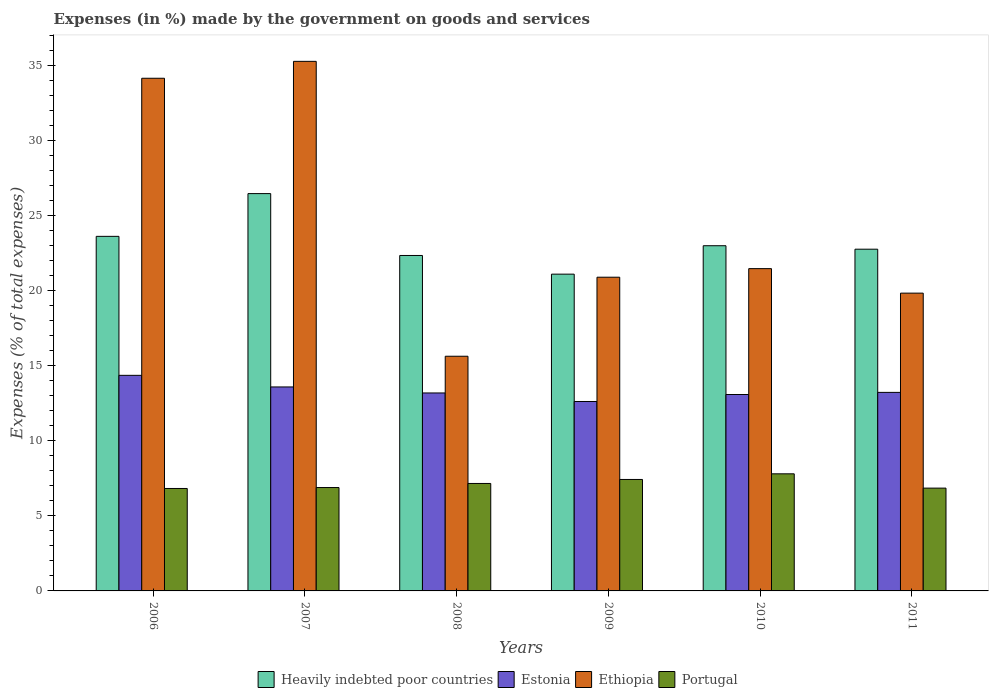How many different coloured bars are there?
Keep it short and to the point. 4. How many bars are there on the 4th tick from the left?
Give a very brief answer. 4. What is the label of the 3rd group of bars from the left?
Give a very brief answer. 2008. In how many cases, is the number of bars for a given year not equal to the number of legend labels?
Your answer should be compact. 0. What is the percentage of expenses made by the government on goods and services in Heavily indebted poor countries in 2010?
Offer a terse response. 23.01. Across all years, what is the maximum percentage of expenses made by the government on goods and services in Ethiopia?
Offer a very short reply. 35.3. Across all years, what is the minimum percentage of expenses made by the government on goods and services in Heavily indebted poor countries?
Keep it short and to the point. 21.11. In which year was the percentage of expenses made by the government on goods and services in Portugal maximum?
Your response must be concise. 2010. In which year was the percentage of expenses made by the government on goods and services in Estonia minimum?
Your answer should be very brief. 2009. What is the total percentage of expenses made by the government on goods and services in Heavily indebted poor countries in the graph?
Give a very brief answer. 139.37. What is the difference between the percentage of expenses made by the government on goods and services in Heavily indebted poor countries in 2009 and that in 2010?
Your answer should be very brief. -1.89. What is the difference between the percentage of expenses made by the government on goods and services in Estonia in 2007 and the percentage of expenses made by the government on goods and services in Heavily indebted poor countries in 2006?
Provide a short and direct response. -10.04. What is the average percentage of expenses made by the government on goods and services in Portugal per year?
Provide a short and direct response. 7.16. In the year 2011, what is the difference between the percentage of expenses made by the government on goods and services in Heavily indebted poor countries and percentage of expenses made by the government on goods and services in Portugal?
Provide a succinct answer. 15.92. In how many years, is the percentage of expenses made by the government on goods and services in Ethiopia greater than 15 %?
Ensure brevity in your answer.  6. What is the ratio of the percentage of expenses made by the government on goods and services in Portugal in 2007 to that in 2011?
Provide a succinct answer. 1.01. What is the difference between the highest and the second highest percentage of expenses made by the government on goods and services in Ethiopia?
Provide a short and direct response. 1.13. What is the difference between the highest and the lowest percentage of expenses made by the government on goods and services in Heavily indebted poor countries?
Keep it short and to the point. 5.37. Is the sum of the percentage of expenses made by the government on goods and services in Heavily indebted poor countries in 2008 and 2011 greater than the maximum percentage of expenses made by the government on goods and services in Estonia across all years?
Provide a short and direct response. Yes. Is it the case that in every year, the sum of the percentage of expenses made by the government on goods and services in Ethiopia and percentage of expenses made by the government on goods and services in Estonia is greater than the sum of percentage of expenses made by the government on goods and services in Portugal and percentage of expenses made by the government on goods and services in Heavily indebted poor countries?
Your response must be concise. Yes. What does the 4th bar from the left in 2007 represents?
Make the answer very short. Portugal. What does the 2nd bar from the right in 2006 represents?
Provide a succinct answer. Ethiopia. Is it the case that in every year, the sum of the percentage of expenses made by the government on goods and services in Heavily indebted poor countries and percentage of expenses made by the government on goods and services in Ethiopia is greater than the percentage of expenses made by the government on goods and services in Portugal?
Give a very brief answer. Yes. How many bars are there?
Your answer should be compact. 24. What is the difference between two consecutive major ticks on the Y-axis?
Your answer should be compact. 5. What is the title of the graph?
Offer a very short reply. Expenses (in %) made by the government on goods and services. What is the label or title of the X-axis?
Offer a terse response. Years. What is the label or title of the Y-axis?
Provide a short and direct response. Expenses (% of total expenses). What is the Expenses (% of total expenses) in Heavily indebted poor countries in 2006?
Make the answer very short. 23.63. What is the Expenses (% of total expenses) in Estonia in 2006?
Offer a terse response. 14.37. What is the Expenses (% of total expenses) of Ethiopia in 2006?
Offer a terse response. 34.17. What is the Expenses (% of total expenses) in Portugal in 2006?
Provide a short and direct response. 6.83. What is the Expenses (% of total expenses) in Heavily indebted poor countries in 2007?
Offer a very short reply. 26.48. What is the Expenses (% of total expenses) in Estonia in 2007?
Provide a short and direct response. 13.6. What is the Expenses (% of total expenses) of Ethiopia in 2007?
Provide a short and direct response. 35.3. What is the Expenses (% of total expenses) of Portugal in 2007?
Ensure brevity in your answer.  6.89. What is the Expenses (% of total expenses) in Heavily indebted poor countries in 2008?
Provide a short and direct response. 22.36. What is the Expenses (% of total expenses) in Estonia in 2008?
Offer a terse response. 13.19. What is the Expenses (% of total expenses) of Ethiopia in 2008?
Make the answer very short. 15.64. What is the Expenses (% of total expenses) of Portugal in 2008?
Keep it short and to the point. 7.16. What is the Expenses (% of total expenses) of Heavily indebted poor countries in 2009?
Keep it short and to the point. 21.11. What is the Expenses (% of total expenses) of Estonia in 2009?
Ensure brevity in your answer.  12.63. What is the Expenses (% of total expenses) of Ethiopia in 2009?
Provide a succinct answer. 20.91. What is the Expenses (% of total expenses) of Portugal in 2009?
Give a very brief answer. 7.43. What is the Expenses (% of total expenses) in Heavily indebted poor countries in 2010?
Keep it short and to the point. 23.01. What is the Expenses (% of total expenses) in Estonia in 2010?
Provide a short and direct response. 13.09. What is the Expenses (% of total expenses) of Ethiopia in 2010?
Ensure brevity in your answer.  21.48. What is the Expenses (% of total expenses) of Portugal in 2010?
Your response must be concise. 7.8. What is the Expenses (% of total expenses) of Heavily indebted poor countries in 2011?
Your answer should be compact. 22.78. What is the Expenses (% of total expenses) of Estonia in 2011?
Your response must be concise. 13.23. What is the Expenses (% of total expenses) of Ethiopia in 2011?
Keep it short and to the point. 19.85. What is the Expenses (% of total expenses) of Portugal in 2011?
Provide a short and direct response. 6.85. Across all years, what is the maximum Expenses (% of total expenses) in Heavily indebted poor countries?
Give a very brief answer. 26.48. Across all years, what is the maximum Expenses (% of total expenses) of Estonia?
Offer a very short reply. 14.37. Across all years, what is the maximum Expenses (% of total expenses) in Ethiopia?
Your response must be concise. 35.3. Across all years, what is the maximum Expenses (% of total expenses) in Portugal?
Your answer should be compact. 7.8. Across all years, what is the minimum Expenses (% of total expenses) in Heavily indebted poor countries?
Give a very brief answer. 21.11. Across all years, what is the minimum Expenses (% of total expenses) in Estonia?
Ensure brevity in your answer.  12.63. Across all years, what is the minimum Expenses (% of total expenses) in Ethiopia?
Offer a very short reply. 15.64. Across all years, what is the minimum Expenses (% of total expenses) of Portugal?
Offer a very short reply. 6.83. What is the total Expenses (% of total expenses) in Heavily indebted poor countries in the graph?
Provide a succinct answer. 139.37. What is the total Expenses (% of total expenses) in Estonia in the graph?
Ensure brevity in your answer.  80.11. What is the total Expenses (% of total expenses) in Ethiopia in the graph?
Ensure brevity in your answer.  147.34. What is the total Expenses (% of total expenses) in Portugal in the graph?
Offer a very short reply. 42.97. What is the difference between the Expenses (% of total expenses) of Heavily indebted poor countries in 2006 and that in 2007?
Provide a short and direct response. -2.85. What is the difference between the Expenses (% of total expenses) of Estonia in 2006 and that in 2007?
Your answer should be very brief. 0.77. What is the difference between the Expenses (% of total expenses) in Ethiopia in 2006 and that in 2007?
Provide a short and direct response. -1.13. What is the difference between the Expenses (% of total expenses) of Portugal in 2006 and that in 2007?
Offer a very short reply. -0.06. What is the difference between the Expenses (% of total expenses) in Heavily indebted poor countries in 2006 and that in 2008?
Make the answer very short. 1.28. What is the difference between the Expenses (% of total expenses) in Estonia in 2006 and that in 2008?
Your response must be concise. 1.17. What is the difference between the Expenses (% of total expenses) in Ethiopia in 2006 and that in 2008?
Offer a terse response. 18.53. What is the difference between the Expenses (% of total expenses) of Portugal in 2006 and that in 2008?
Offer a very short reply. -0.33. What is the difference between the Expenses (% of total expenses) in Heavily indebted poor countries in 2006 and that in 2009?
Your answer should be very brief. 2.52. What is the difference between the Expenses (% of total expenses) in Estonia in 2006 and that in 2009?
Offer a terse response. 1.74. What is the difference between the Expenses (% of total expenses) of Ethiopia in 2006 and that in 2009?
Offer a very short reply. 13.26. What is the difference between the Expenses (% of total expenses) in Portugal in 2006 and that in 2009?
Keep it short and to the point. -0.6. What is the difference between the Expenses (% of total expenses) of Heavily indebted poor countries in 2006 and that in 2010?
Your answer should be very brief. 0.62. What is the difference between the Expenses (% of total expenses) of Estonia in 2006 and that in 2010?
Keep it short and to the point. 1.28. What is the difference between the Expenses (% of total expenses) in Ethiopia in 2006 and that in 2010?
Give a very brief answer. 12.69. What is the difference between the Expenses (% of total expenses) in Portugal in 2006 and that in 2010?
Keep it short and to the point. -0.98. What is the difference between the Expenses (% of total expenses) of Heavily indebted poor countries in 2006 and that in 2011?
Give a very brief answer. 0.86. What is the difference between the Expenses (% of total expenses) in Estonia in 2006 and that in 2011?
Make the answer very short. 1.14. What is the difference between the Expenses (% of total expenses) in Ethiopia in 2006 and that in 2011?
Offer a terse response. 14.32. What is the difference between the Expenses (% of total expenses) of Portugal in 2006 and that in 2011?
Your answer should be compact. -0.02. What is the difference between the Expenses (% of total expenses) of Heavily indebted poor countries in 2007 and that in 2008?
Offer a very short reply. 4.12. What is the difference between the Expenses (% of total expenses) of Estonia in 2007 and that in 2008?
Ensure brevity in your answer.  0.4. What is the difference between the Expenses (% of total expenses) of Ethiopia in 2007 and that in 2008?
Your answer should be compact. 19.65. What is the difference between the Expenses (% of total expenses) in Portugal in 2007 and that in 2008?
Provide a short and direct response. -0.27. What is the difference between the Expenses (% of total expenses) of Heavily indebted poor countries in 2007 and that in 2009?
Your answer should be very brief. 5.37. What is the difference between the Expenses (% of total expenses) of Estonia in 2007 and that in 2009?
Ensure brevity in your answer.  0.97. What is the difference between the Expenses (% of total expenses) in Ethiopia in 2007 and that in 2009?
Keep it short and to the point. 14.39. What is the difference between the Expenses (% of total expenses) in Portugal in 2007 and that in 2009?
Offer a terse response. -0.54. What is the difference between the Expenses (% of total expenses) of Heavily indebted poor countries in 2007 and that in 2010?
Your response must be concise. 3.47. What is the difference between the Expenses (% of total expenses) of Estonia in 2007 and that in 2010?
Provide a short and direct response. 0.5. What is the difference between the Expenses (% of total expenses) in Ethiopia in 2007 and that in 2010?
Give a very brief answer. 13.81. What is the difference between the Expenses (% of total expenses) in Portugal in 2007 and that in 2010?
Provide a succinct answer. -0.91. What is the difference between the Expenses (% of total expenses) in Heavily indebted poor countries in 2007 and that in 2011?
Keep it short and to the point. 3.71. What is the difference between the Expenses (% of total expenses) in Estonia in 2007 and that in 2011?
Give a very brief answer. 0.36. What is the difference between the Expenses (% of total expenses) of Ethiopia in 2007 and that in 2011?
Your response must be concise. 15.45. What is the difference between the Expenses (% of total expenses) of Portugal in 2007 and that in 2011?
Offer a very short reply. 0.04. What is the difference between the Expenses (% of total expenses) in Heavily indebted poor countries in 2008 and that in 2009?
Provide a succinct answer. 1.24. What is the difference between the Expenses (% of total expenses) of Estonia in 2008 and that in 2009?
Ensure brevity in your answer.  0.57. What is the difference between the Expenses (% of total expenses) of Ethiopia in 2008 and that in 2009?
Your answer should be compact. -5.27. What is the difference between the Expenses (% of total expenses) of Portugal in 2008 and that in 2009?
Make the answer very short. -0.27. What is the difference between the Expenses (% of total expenses) in Heavily indebted poor countries in 2008 and that in 2010?
Give a very brief answer. -0.65. What is the difference between the Expenses (% of total expenses) in Estonia in 2008 and that in 2010?
Keep it short and to the point. 0.1. What is the difference between the Expenses (% of total expenses) in Ethiopia in 2008 and that in 2010?
Your response must be concise. -5.84. What is the difference between the Expenses (% of total expenses) of Portugal in 2008 and that in 2010?
Provide a succinct answer. -0.64. What is the difference between the Expenses (% of total expenses) in Heavily indebted poor countries in 2008 and that in 2011?
Provide a succinct answer. -0.42. What is the difference between the Expenses (% of total expenses) of Estonia in 2008 and that in 2011?
Ensure brevity in your answer.  -0.04. What is the difference between the Expenses (% of total expenses) of Ethiopia in 2008 and that in 2011?
Your answer should be compact. -4.21. What is the difference between the Expenses (% of total expenses) of Portugal in 2008 and that in 2011?
Ensure brevity in your answer.  0.31. What is the difference between the Expenses (% of total expenses) in Heavily indebted poor countries in 2009 and that in 2010?
Your answer should be compact. -1.89. What is the difference between the Expenses (% of total expenses) of Estonia in 2009 and that in 2010?
Offer a terse response. -0.47. What is the difference between the Expenses (% of total expenses) of Ethiopia in 2009 and that in 2010?
Offer a very short reply. -0.57. What is the difference between the Expenses (% of total expenses) in Portugal in 2009 and that in 2010?
Your response must be concise. -0.38. What is the difference between the Expenses (% of total expenses) in Heavily indebted poor countries in 2009 and that in 2011?
Ensure brevity in your answer.  -1.66. What is the difference between the Expenses (% of total expenses) in Estonia in 2009 and that in 2011?
Give a very brief answer. -0.61. What is the difference between the Expenses (% of total expenses) in Ethiopia in 2009 and that in 2011?
Ensure brevity in your answer.  1.06. What is the difference between the Expenses (% of total expenses) of Portugal in 2009 and that in 2011?
Provide a succinct answer. 0.58. What is the difference between the Expenses (% of total expenses) in Heavily indebted poor countries in 2010 and that in 2011?
Give a very brief answer. 0.23. What is the difference between the Expenses (% of total expenses) in Estonia in 2010 and that in 2011?
Keep it short and to the point. -0.14. What is the difference between the Expenses (% of total expenses) of Ethiopia in 2010 and that in 2011?
Your answer should be compact. 1.63. What is the difference between the Expenses (% of total expenses) in Portugal in 2010 and that in 2011?
Keep it short and to the point. 0.95. What is the difference between the Expenses (% of total expenses) of Heavily indebted poor countries in 2006 and the Expenses (% of total expenses) of Estonia in 2007?
Ensure brevity in your answer.  10.04. What is the difference between the Expenses (% of total expenses) in Heavily indebted poor countries in 2006 and the Expenses (% of total expenses) in Ethiopia in 2007?
Give a very brief answer. -11.66. What is the difference between the Expenses (% of total expenses) of Heavily indebted poor countries in 2006 and the Expenses (% of total expenses) of Portugal in 2007?
Provide a succinct answer. 16.74. What is the difference between the Expenses (% of total expenses) in Estonia in 2006 and the Expenses (% of total expenses) in Ethiopia in 2007?
Ensure brevity in your answer.  -20.93. What is the difference between the Expenses (% of total expenses) of Estonia in 2006 and the Expenses (% of total expenses) of Portugal in 2007?
Make the answer very short. 7.48. What is the difference between the Expenses (% of total expenses) in Ethiopia in 2006 and the Expenses (% of total expenses) in Portugal in 2007?
Your answer should be compact. 27.28. What is the difference between the Expenses (% of total expenses) in Heavily indebted poor countries in 2006 and the Expenses (% of total expenses) in Estonia in 2008?
Provide a succinct answer. 10.44. What is the difference between the Expenses (% of total expenses) in Heavily indebted poor countries in 2006 and the Expenses (% of total expenses) in Ethiopia in 2008?
Offer a very short reply. 7.99. What is the difference between the Expenses (% of total expenses) in Heavily indebted poor countries in 2006 and the Expenses (% of total expenses) in Portugal in 2008?
Offer a very short reply. 16.47. What is the difference between the Expenses (% of total expenses) in Estonia in 2006 and the Expenses (% of total expenses) in Ethiopia in 2008?
Ensure brevity in your answer.  -1.27. What is the difference between the Expenses (% of total expenses) of Estonia in 2006 and the Expenses (% of total expenses) of Portugal in 2008?
Your answer should be compact. 7.21. What is the difference between the Expenses (% of total expenses) in Ethiopia in 2006 and the Expenses (% of total expenses) in Portugal in 2008?
Give a very brief answer. 27.01. What is the difference between the Expenses (% of total expenses) of Heavily indebted poor countries in 2006 and the Expenses (% of total expenses) of Estonia in 2009?
Ensure brevity in your answer.  11.01. What is the difference between the Expenses (% of total expenses) in Heavily indebted poor countries in 2006 and the Expenses (% of total expenses) in Ethiopia in 2009?
Your answer should be very brief. 2.72. What is the difference between the Expenses (% of total expenses) of Heavily indebted poor countries in 2006 and the Expenses (% of total expenses) of Portugal in 2009?
Offer a very short reply. 16.2. What is the difference between the Expenses (% of total expenses) of Estonia in 2006 and the Expenses (% of total expenses) of Ethiopia in 2009?
Keep it short and to the point. -6.54. What is the difference between the Expenses (% of total expenses) in Estonia in 2006 and the Expenses (% of total expenses) in Portugal in 2009?
Provide a succinct answer. 6.94. What is the difference between the Expenses (% of total expenses) of Ethiopia in 2006 and the Expenses (% of total expenses) of Portugal in 2009?
Your answer should be compact. 26.74. What is the difference between the Expenses (% of total expenses) of Heavily indebted poor countries in 2006 and the Expenses (% of total expenses) of Estonia in 2010?
Offer a terse response. 10.54. What is the difference between the Expenses (% of total expenses) of Heavily indebted poor countries in 2006 and the Expenses (% of total expenses) of Ethiopia in 2010?
Provide a short and direct response. 2.15. What is the difference between the Expenses (% of total expenses) of Heavily indebted poor countries in 2006 and the Expenses (% of total expenses) of Portugal in 2010?
Keep it short and to the point. 15.83. What is the difference between the Expenses (% of total expenses) of Estonia in 2006 and the Expenses (% of total expenses) of Ethiopia in 2010?
Make the answer very short. -7.11. What is the difference between the Expenses (% of total expenses) in Estonia in 2006 and the Expenses (% of total expenses) in Portugal in 2010?
Provide a short and direct response. 6.56. What is the difference between the Expenses (% of total expenses) of Ethiopia in 2006 and the Expenses (% of total expenses) of Portugal in 2010?
Provide a succinct answer. 26.37. What is the difference between the Expenses (% of total expenses) in Heavily indebted poor countries in 2006 and the Expenses (% of total expenses) in Estonia in 2011?
Your response must be concise. 10.4. What is the difference between the Expenses (% of total expenses) in Heavily indebted poor countries in 2006 and the Expenses (% of total expenses) in Ethiopia in 2011?
Provide a succinct answer. 3.78. What is the difference between the Expenses (% of total expenses) of Heavily indebted poor countries in 2006 and the Expenses (% of total expenses) of Portugal in 2011?
Your answer should be very brief. 16.78. What is the difference between the Expenses (% of total expenses) of Estonia in 2006 and the Expenses (% of total expenses) of Ethiopia in 2011?
Your answer should be compact. -5.48. What is the difference between the Expenses (% of total expenses) of Estonia in 2006 and the Expenses (% of total expenses) of Portugal in 2011?
Offer a terse response. 7.52. What is the difference between the Expenses (% of total expenses) of Ethiopia in 2006 and the Expenses (% of total expenses) of Portugal in 2011?
Ensure brevity in your answer.  27.32. What is the difference between the Expenses (% of total expenses) of Heavily indebted poor countries in 2007 and the Expenses (% of total expenses) of Estonia in 2008?
Your answer should be very brief. 13.29. What is the difference between the Expenses (% of total expenses) in Heavily indebted poor countries in 2007 and the Expenses (% of total expenses) in Ethiopia in 2008?
Make the answer very short. 10.84. What is the difference between the Expenses (% of total expenses) in Heavily indebted poor countries in 2007 and the Expenses (% of total expenses) in Portugal in 2008?
Offer a terse response. 19.32. What is the difference between the Expenses (% of total expenses) of Estonia in 2007 and the Expenses (% of total expenses) of Ethiopia in 2008?
Offer a terse response. -2.05. What is the difference between the Expenses (% of total expenses) of Estonia in 2007 and the Expenses (% of total expenses) of Portugal in 2008?
Ensure brevity in your answer.  6.43. What is the difference between the Expenses (% of total expenses) in Ethiopia in 2007 and the Expenses (% of total expenses) in Portugal in 2008?
Offer a very short reply. 28.13. What is the difference between the Expenses (% of total expenses) of Heavily indebted poor countries in 2007 and the Expenses (% of total expenses) of Estonia in 2009?
Your answer should be compact. 13.86. What is the difference between the Expenses (% of total expenses) of Heavily indebted poor countries in 2007 and the Expenses (% of total expenses) of Ethiopia in 2009?
Offer a very short reply. 5.57. What is the difference between the Expenses (% of total expenses) of Heavily indebted poor countries in 2007 and the Expenses (% of total expenses) of Portugal in 2009?
Ensure brevity in your answer.  19.05. What is the difference between the Expenses (% of total expenses) in Estonia in 2007 and the Expenses (% of total expenses) in Ethiopia in 2009?
Your answer should be compact. -7.31. What is the difference between the Expenses (% of total expenses) of Estonia in 2007 and the Expenses (% of total expenses) of Portugal in 2009?
Keep it short and to the point. 6.17. What is the difference between the Expenses (% of total expenses) of Ethiopia in 2007 and the Expenses (% of total expenses) of Portugal in 2009?
Your answer should be very brief. 27.87. What is the difference between the Expenses (% of total expenses) of Heavily indebted poor countries in 2007 and the Expenses (% of total expenses) of Estonia in 2010?
Your response must be concise. 13.39. What is the difference between the Expenses (% of total expenses) in Heavily indebted poor countries in 2007 and the Expenses (% of total expenses) in Ethiopia in 2010?
Offer a very short reply. 5. What is the difference between the Expenses (% of total expenses) in Heavily indebted poor countries in 2007 and the Expenses (% of total expenses) in Portugal in 2010?
Offer a very short reply. 18.68. What is the difference between the Expenses (% of total expenses) of Estonia in 2007 and the Expenses (% of total expenses) of Ethiopia in 2010?
Make the answer very short. -7.89. What is the difference between the Expenses (% of total expenses) of Estonia in 2007 and the Expenses (% of total expenses) of Portugal in 2010?
Give a very brief answer. 5.79. What is the difference between the Expenses (% of total expenses) of Ethiopia in 2007 and the Expenses (% of total expenses) of Portugal in 2010?
Provide a succinct answer. 27.49. What is the difference between the Expenses (% of total expenses) of Heavily indebted poor countries in 2007 and the Expenses (% of total expenses) of Estonia in 2011?
Provide a succinct answer. 13.25. What is the difference between the Expenses (% of total expenses) in Heavily indebted poor countries in 2007 and the Expenses (% of total expenses) in Ethiopia in 2011?
Your answer should be very brief. 6.63. What is the difference between the Expenses (% of total expenses) of Heavily indebted poor countries in 2007 and the Expenses (% of total expenses) of Portugal in 2011?
Ensure brevity in your answer.  19.63. What is the difference between the Expenses (% of total expenses) of Estonia in 2007 and the Expenses (% of total expenses) of Ethiopia in 2011?
Provide a short and direct response. -6.25. What is the difference between the Expenses (% of total expenses) of Estonia in 2007 and the Expenses (% of total expenses) of Portugal in 2011?
Provide a short and direct response. 6.74. What is the difference between the Expenses (% of total expenses) of Ethiopia in 2007 and the Expenses (% of total expenses) of Portugal in 2011?
Your answer should be compact. 28.44. What is the difference between the Expenses (% of total expenses) in Heavily indebted poor countries in 2008 and the Expenses (% of total expenses) in Estonia in 2009?
Your response must be concise. 9.73. What is the difference between the Expenses (% of total expenses) of Heavily indebted poor countries in 2008 and the Expenses (% of total expenses) of Ethiopia in 2009?
Make the answer very short. 1.45. What is the difference between the Expenses (% of total expenses) of Heavily indebted poor countries in 2008 and the Expenses (% of total expenses) of Portugal in 2009?
Provide a short and direct response. 14.93. What is the difference between the Expenses (% of total expenses) of Estonia in 2008 and the Expenses (% of total expenses) of Ethiopia in 2009?
Ensure brevity in your answer.  -7.71. What is the difference between the Expenses (% of total expenses) of Estonia in 2008 and the Expenses (% of total expenses) of Portugal in 2009?
Offer a very short reply. 5.77. What is the difference between the Expenses (% of total expenses) of Ethiopia in 2008 and the Expenses (% of total expenses) of Portugal in 2009?
Your answer should be very brief. 8.21. What is the difference between the Expenses (% of total expenses) of Heavily indebted poor countries in 2008 and the Expenses (% of total expenses) of Estonia in 2010?
Ensure brevity in your answer.  9.27. What is the difference between the Expenses (% of total expenses) in Heavily indebted poor countries in 2008 and the Expenses (% of total expenses) in Ethiopia in 2010?
Provide a short and direct response. 0.88. What is the difference between the Expenses (% of total expenses) of Heavily indebted poor countries in 2008 and the Expenses (% of total expenses) of Portugal in 2010?
Provide a short and direct response. 14.55. What is the difference between the Expenses (% of total expenses) in Estonia in 2008 and the Expenses (% of total expenses) in Ethiopia in 2010?
Make the answer very short. -8.29. What is the difference between the Expenses (% of total expenses) in Estonia in 2008 and the Expenses (% of total expenses) in Portugal in 2010?
Make the answer very short. 5.39. What is the difference between the Expenses (% of total expenses) in Ethiopia in 2008 and the Expenses (% of total expenses) in Portugal in 2010?
Your answer should be compact. 7.84. What is the difference between the Expenses (% of total expenses) in Heavily indebted poor countries in 2008 and the Expenses (% of total expenses) in Estonia in 2011?
Keep it short and to the point. 9.12. What is the difference between the Expenses (% of total expenses) of Heavily indebted poor countries in 2008 and the Expenses (% of total expenses) of Ethiopia in 2011?
Your answer should be very brief. 2.51. What is the difference between the Expenses (% of total expenses) in Heavily indebted poor countries in 2008 and the Expenses (% of total expenses) in Portugal in 2011?
Offer a very short reply. 15.51. What is the difference between the Expenses (% of total expenses) in Estonia in 2008 and the Expenses (% of total expenses) in Ethiopia in 2011?
Make the answer very short. -6.65. What is the difference between the Expenses (% of total expenses) in Estonia in 2008 and the Expenses (% of total expenses) in Portugal in 2011?
Offer a terse response. 6.34. What is the difference between the Expenses (% of total expenses) of Ethiopia in 2008 and the Expenses (% of total expenses) of Portugal in 2011?
Give a very brief answer. 8.79. What is the difference between the Expenses (% of total expenses) in Heavily indebted poor countries in 2009 and the Expenses (% of total expenses) in Estonia in 2010?
Offer a very short reply. 8.02. What is the difference between the Expenses (% of total expenses) in Heavily indebted poor countries in 2009 and the Expenses (% of total expenses) in Ethiopia in 2010?
Give a very brief answer. -0.37. What is the difference between the Expenses (% of total expenses) in Heavily indebted poor countries in 2009 and the Expenses (% of total expenses) in Portugal in 2010?
Your answer should be very brief. 13.31. What is the difference between the Expenses (% of total expenses) in Estonia in 2009 and the Expenses (% of total expenses) in Ethiopia in 2010?
Your response must be concise. -8.86. What is the difference between the Expenses (% of total expenses) of Estonia in 2009 and the Expenses (% of total expenses) of Portugal in 2010?
Your answer should be very brief. 4.82. What is the difference between the Expenses (% of total expenses) in Ethiopia in 2009 and the Expenses (% of total expenses) in Portugal in 2010?
Your answer should be compact. 13.1. What is the difference between the Expenses (% of total expenses) of Heavily indebted poor countries in 2009 and the Expenses (% of total expenses) of Estonia in 2011?
Ensure brevity in your answer.  7.88. What is the difference between the Expenses (% of total expenses) in Heavily indebted poor countries in 2009 and the Expenses (% of total expenses) in Ethiopia in 2011?
Ensure brevity in your answer.  1.27. What is the difference between the Expenses (% of total expenses) in Heavily indebted poor countries in 2009 and the Expenses (% of total expenses) in Portugal in 2011?
Ensure brevity in your answer.  14.26. What is the difference between the Expenses (% of total expenses) of Estonia in 2009 and the Expenses (% of total expenses) of Ethiopia in 2011?
Your response must be concise. -7.22. What is the difference between the Expenses (% of total expenses) in Estonia in 2009 and the Expenses (% of total expenses) in Portugal in 2011?
Your answer should be compact. 5.77. What is the difference between the Expenses (% of total expenses) in Ethiopia in 2009 and the Expenses (% of total expenses) in Portugal in 2011?
Your answer should be very brief. 14.06. What is the difference between the Expenses (% of total expenses) in Heavily indebted poor countries in 2010 and the Expenses (% of total expenses) in Estonia in 2011?
Offer a very short reply. 9.78. What is the difference between the Expenses (% of total expenses) in Heavily indebted poor countries in 2010 and the Expenses (% of total expenses) in Ethiopia in 2011?
Give a very brief answer. 3.16. What is the difference between the Expenses (% of total expenses) in Heavily indebted poor countries in 2010 and the Expenses (% of total expenses) in Portugal in 2011?
Provide a succinct answer. 16.16. What is the difference between the Expenses (% of total expenses) of Estonia in 2010 and the Expenses (% of total expenses) of Ethiopia in 2011?
Offer a very short reply. -6.76. What is the difference between the Expenses (% of total expenses) in Estonia in 2010 and the Expenses (% of total expenses) in Portugal in 2011?
Give a very brief answer. 6.24. What is the difference between the Expenses (% of total expenses) in Ethiopia in 2010 and the Expenses (% of total expenses) in Portugal in 2011?
Your answer should be very brief. 14.63. What is the average Expenses (% of total expenses) of Heavily indebted poor countries per year?
Ensure brevity in your answer.  23.23. What is the average Expenses (% of total expenses) in Estonia per year?
Offer a terse response. 13.35. What is the average Expenses (% of total expenses) in Ethiopia per year?
Your answer should be compact. 24.56. What is the average Expenses (% of total expenses) in Portugal per year?
Offer a very short reply. 7.16. In the year 2006, what is the difference between the Expenses (% of total expenses) in Heavily indebted poor countries and Expenses (% of total expenses) in Estonia?
Provide a short and direct response. 9.26. In the year 2006, what is the difference between the Expenses (% of total expenses) in Heavily indebted poor countries and Expenses (% of total expenses) in Ethiopia?
Your response must be concise. -10.54. In the year 2006, what is the difference between the Expenses (% of total expenses) in Heavily indebted poor countries and Expenses (% of total expenses) in Portugal?
Give a very brief answer. 16.8. In the year 2006, what is the difference between the Expenses (% of total expenses) in Estonia and Expenses (% of total expenses) in Ethiopia?
Ensure brevity in your answer.  -19.8. In the year 2006, what is the difference between the Expenses (% of total expenses) in Estonia and Expenses (% of total expenses) in Portugal?
Make the answer very short. 7.54. In the year 2006, what is the difference between the Expenses (% of total expenses) in Ethiopia and Expenses (% of total expenses) in Portugal?
Make the answer very short. 27.34. In the year 2007, what is the difference between the Expenses (% of total expenses) of Heavily indebted poor countries and Expenses (% of total expenses) of Estonia?
Your answer should be very brief. 12.89. In the year 2007, what is the difference between the Expenses (% of total expenses) in Heavily indebted poor countries and Expenses (% of total expenses) in Ethiopia?
Provide a succinct answer. -8.81. In the year 2007, what is the difference between the Expenses (% of total expenses) in Heavily indebted poor countries and Expenses (% of total expenses) in Portugal?
Make the answer very short. 19.59. In the year 2007, what is the difference between the Expenses (% of total expenses) of Estonia and Expenses (% of total expenses) of Ethiopia?
Make the answer very short. -21.7. In the year 2007, what is the difference between the Expenses (% of total expenses) of Estonia and Expenses (% of total expenses) of Portugal?
Offer a very short reply. 6.71. In the year 2007, what is the difference between the Expenses (% of total expenses) in Ethiopia and Expenses (% of total expenses) in Portugal?
Offer a terse response. 28.41. In the year 2008, what is the difference between the Expenses (% of total expenses) of Heavily indebted poor countries and Expenses (% of total expenses) of Estonia?
Provide a short and direct response. 9.16. In the year 2008, what is the difference between the Expenses (% of total expenses) of Heavily indebted poor countries and Expenses (% of total expenses) of Ethiopia?
Keep it short and to the point. 6.72. In the year 2008, what is the difference between the Expenses (% of total expenses) of Heavily indebted poor countries and Expenses (% of total expenses) of Portugal?
Your response must be concise. 15.2. In the year 2008, what is the difference between the Expenses (% of total expenses) in Estonia and Expenses (% of total expenses) in Ethiopia?
Make the answer very short. -2.45. In the year 2008, what is the difference between the Expenses (% of total expenses) of Estonia and Expenses (% of total expenses) of Portugal?
Your answer should be very brief. 6.03. In the year 2008, what is the difference between the Expenses (% of total expenses) of Ethiopia and Expenses (% of total expenses) of Portugal?
Provide a short and direct response. 8.48. In the year 2009, what is the difference between the Expenses (% of total expenses) in Heavily indebted poor countries and Expenses (% of total expenses) in Estonia?
Your response must be concise. 8.49. In the year 2009, what is the difference between the Expenses (% of total expenses) in Heavily indebted poor countries and Expenses (% of total expenses) in Ethiopia?
Your response must be concise. 0.2. In the year 2009, what is the difference between the Expenses (% of total expenses) of Heavily indebted poor countries and Expenses (% of total expenses) of Portugal?
Make the answer very short. 13.68. In the year 2009, what is the difference between the Expenses (% of total expenses) in Estonia and Expenses (% of total expenses) in Ethiopia?
Provide a short and direct response. -8.28. In the year 2009, what is the difference between the Expenses (% of total expenses) of Estonia and Expenses (% of total expenses) of Portugal?
Provide a short and direct response. 5.2. In the year 2009, what is the difference between the Expenses (% of total expenses) of Ethiopia and Expenses (% of total expenses) of Portugal?
Offer a very short reply. 13.48. In the year 2010, what is the difference between the Expenses (% of total expenses) in Heavily indebted poor countries and Expenses (% of total expenses) in Estonia?
Your answer should be compact. 9.92. In the year 2010, what is the difference between the Expenses (% of total expenses) in Heavily indebted poor countries and Expenses (% of total expenses) in Ethiopia?
Offer a very short reply. 1.53. In the year 2010, what is the difference between the Expenses (% of total expenses) in Heavily indebted poor countries and Expenses (% of total expenses) in Portugal?
Offer a very short reply. 15.2. In the year 2010, what is the difference between the Expenses (% of total expenses) in Estonia and Expenses (% of total expenses) in Ethiopia?
Make the answer very short. -8.39. In the year 2010, what is the difference between the Expenses (% of total expenses) in Estonia and Expenses (% of total expenses) in Portugal?
Offer a terse response. 5.29. In the year 2010, what is the difference between the Expenses (% of total expenses) of Ethiopia and Expenses (% of total expenses) of Portugal?
Your answer should be compact. 13.68. In the year 2011, what is the difference between the Expenses (% of total expenses) in Heavily indebted poor countries and Expenses (% of total expenses) in Estonia?
Offer a very short reply. 9.54. In the year 2011, what is the difference between the Expenses (% of total expenses) of Heavily indebted poor countries and Expenses (% of total expenses) of Ethiopia?
Your answer should be compact. 2.93. In the year 2011, what is the difference between the Expenses (% of total expenses) of Heavily indebted poor countries and Expenses (% of total expenses) of Portugal?
Provide a succinct answer. 15.92. In the year 2011, what is the difference between the Expenses (% of total expenses) in Estonia and Expenses (% of total expenses) in Ethiopia?
Your answer should be compact. -6.62. In the year 2011, what is the difference between the Expenses (% of total expenses) in Estonia and Expenses (% of total expenses) in Portugal?
Give a very brief answer. 6.38. In the year 2011, what is the difference between the Expenses (% of total expenses) of Ethiopia and Expenses (% of total expenses) of Portugal?
Make the answer very short. 13. What is the ratio of the Expenses (% of total expenses) in Heavily indebted poor countries in 2006 to that in 2007?
Your answer should be very brief. 0.89. What is the ratio of the Expenses (% of total expenses) in Estonia in 2006 to that in 2007?
Keep it short and to the point. 1.06. What is the ratio of the Expenses (% of total expenses) of Ethiopia in 2006 to that in 2007?
Provide a short and direct response. 0.97. What is the ratio of the Expenses (% of total expenses) in Heavily indebted poor countries in 2006 to that in 2008?
Provide a succinct answer. 1.06. What is the ratio of the Expenses (% of total expenses) of Estonia in 2006 to that in 2008?
Make the answer very short. 1.09. What is the ratio of the Expenses (% of total expenses) in Ethiopia in 2006 to that in 2008?
Your answer should be very brief. 2.18. What is the ratio of the Expenses (% of total expenses) in Portugal in 2006 to that in 2008?
Your answer should be compact. 0.95. What is the ratio of the Expenses (% of total expenses) in Heavily indebted poor countries in 2006 to that in 2009?
Ensure brevity in your answer.  1.12. What is the ratio of the Expenses (% of total expenses) of Estonia in 2006 to that in 2009?
Your answer should be very brief. 1.14. What is the ratio of the Expenses (% of total expenses) of Ethiopia in 2006 to that in 2009?
Offer a terse response. 1.63. What is the ratio of the Expenses (% of total expenses) of Portugal in 2006 to that in 2009?
Your response must be concise. 0.92. What is the ratio of the Expenses (% of total expenses) of Heavily indebted poor countries in 2006 to that in 2010?
Keep it short and to the point. 1.03. What is the ratio of the Expenses (% of total expenses) in Estonia in 2006 to that in 2010?
Offer a very short reply. 1.1. What is the ratio of the Expenses (% of total expenses) of Ethiopia in 2006 to that in 2010?
Ensure brevity in your answer.  1.59. What is the ratio of the Expenses (% of total expenses) in Portugal in 2006 to that in 2010?
Your response must be concise. 0.87. What is the ratio of the Expenses (% of total expenses) in Heavily indebted poor countries in 2006 to that in 2011?
Make the answer very short. 1.04. What is the ratio of the Expenses (% of total expenses) of Estonia in 2006 to that in 2011?
Provide a succinct answer. 1.09. What is the ratio of the Expenses (% of total expenses) of Ethiopia in 2006 to that in 2011?
Your answer should be very brief. 1.72. What is the ratio of the Expenses (% of total expenses) of Portugal in 2006 to that in 2011?
Make the answer very short. 1. What is the ratio of the Expenses (% of total expenses) of Heavily indebted poor countries in 2007 to that in 2008?
Offer a very short reply. 1.18. What is the ratio of the Expenses (% of total expenses) in Estonia in 2007 to that in 2008?
Your response must be concise. 1.03. What is the ratio of the Expenses (% of total expenses) in Ethiopia in 2007 to that in 2008?
Offer a terse response. 2.26. What is the ratio of the Expenses (% of total expenses) of Portugal in 2007 to that in 2008?
Keep it short and to the point. 0.96. What is the ratio of the Expenses (% of total expenses) of Heavily indebted poor countries in 2007 to that in 2009?
Provide a short and direct response. 1.25. What is the ratio of the Expenses (% of total expenses) in Ethiopia in 2007 to that in 2009?
Your answer should be compact. 1.69. What is the ratio of the Expenses (% of total expenses) in Portugal in 2007 to that in 2009?
Keep it short and to the point. 0.93. What is the ratio of the Expenses (% of total expenses) of Heavily indebted poor countries in 2007 to that in 2010?
Make the answer very short. 1.15. What is the ratio of the Expenses (% of total expenses) of Estonia in 2007 to that in 2010?
Make the answer very short. 1.04. What is the ratio of the Expenses (% of total expenses) of Ethiopia in 2007 to that in 2010?
Keep it short and to the point. 1.64. What is the ratio of the Expenses (% of total expenses) in Portugal in 2007 to that in 2010?
Make the answer very short. 0.88. What is the ratio of the Expenses (% of total expenses) in Heavily indebted poor countries in 2007 to that in 2011?
Give a very brief answer. 1.16. What is the ratio of the Expenses (% of total expenses) of Estonia in 2007 to that in 2011?
Keep it short and to the point. 1.03. What is the ratio of the Expenses (% of total expenses) of Ethiopia in 2007 to that in 2011?
Offer a very short reply. 1.78. What is the ratio of the Expenses (% of total expenses) of Portugal in 2007 to that in 2011?
Keep it short and to the point. 1.01. What is the ratio of the Expenses (% of total expenses) of Heavily indebted poor countries in 2008 to that in 2009?
Your response must be concise. 1.06. What is the ratio of the Expenses (% of total expenses) of Estonia in 2008 to that in 2009?
Offer a terse response. 1.05. What is the ratio of the Expenses (% of total expenses) in Ethiopia in 2008 to that in 2009?
Offer a very short reply. 0.75. What is the ratio of the Expenses (% of total expenses) in Portugal in 2008 to that in 2009?
Give a very brief answer. 0.96. What is the ratio of the Expenses (% of total expenses) of Heavily indebted poor countries in 2008 to that in 2010?
Give a very brief answer. 0.97. What is the ratio of the Expenses (% of total expenses) of Estonia in 2008 to that in 2010?
Your response must be concise. 1.01. What is the ratio of the Expenses (% of total expenses) of Ethiopia in 2008 to that in 2010?
Offer a very short reply. 0.73. What is the ratio of the Expenses (% of total expenses) of Portugal in 2008 to that in 2010?
Provide a succinct answer. 0.92. What is the ratio of the Expenses (% of total expenses) in Heavily indebted poor countries in 2008 to that in 2011?
Give a very brief answer. 0.98. What is the ratio of the Expenses (% of total expenses) of Estonia in 2008 to that in 2011?
Your answer should be very brief. 1. What is the ratio of the Expenses (% of total expenses) of Ethiopia in 2008 to that in 2011?
Provide a succinct answer. 0.79. What is the ratio of the Expenses (% of total expenses) in Portugal in 2008 to that in 2011?
Offer a terse response. 1.05. What is the ratio of the Expenses (% of total expenses) in Heavily indebted poor countries in 2009 to that in 2010?
Make the answer very short. 0.92. What is the ratio of the Expenses (% of total expenses) of Estonia in 2009 to that in 2010?
Your response must be concise. 0.96. What is the ratio of the Expenses (% of total expenses) in Ethiopia in 2009 to that in 2010?
Make the answer very short. 0.97. What is the ratio of the Expenses (% of total expenses) of Portugal in 2009 to that in 2010?
Offer a terse response. 0.95. What is the ratio of the Expenses (% of total expenses) in Heavily indebted poor countries in 2009 to that in 2011?
Your answer should be compact. 0.93. What is the ratio of the Expenses (% of total expenses) in Estonia in 2009 to that in 2011?
Make the answer very short. 0.95. What is the ratio of the Expenses (% of total expenses) of Ethiopia in 2009 to that in 2011?
Offer a very short reply. 1.05. What is the ratio of the Expenses (% of total expenses) of Portugal in 2009 to that in 2011?
Give a very brief answer. 1.08. What is the ratio of the Expenses (% of total expenses) in Heavily indebted poor countries in 2010 to that in 2011?
Offer a terse response. 1.01. What is the ratio of the Expenses (% of total expenses) of Estonia in 2010 to that in 2011?
Offer a very short reply. 0.99. What is the ratio of the Expenses (% of total expenses) of Ethiopia in 2010 to that in 2011?
Provide a short and direct response. 1.08. What is the ratio of the Expenses (% of total expenses) in Portugal in 2010 to that in 2011?
Your answer should be very brief. 1.14. What is the difference between the highest and the second highest Expenses (% of total expenses) in Heavily indebted poor countries?
Ensure brevity in your answer.  2.85. What is the difference between the highest and the second highest Expenses (% of total expenses) in Estonia?
Ensure brevity in your answer.  0.77. What is the difference between the highest and the second highest Expenses (% of total expenses) in Ethiopia?
Provide a succinct answer. 1.13. What is the difference between the highest and the second highest Expenses (% of total expenses) of Portugal?
Provide a short and direct response. 0.38. What is the difference between the highest and the lowest Expenses (% of total expenses) of Heavily indebted poor countries?
Provide a short and direct response. 5.37. What is the difference between the highest and the lowest Expenses (% of total expenses) in Estonia?
Your response must be concise. 1.74. What is the difference between the highest and the lowest Expenses (% of total expenses) in Ethiopia?
Keep it short and to the point. 19.65. What is the difference between the highest and the lowest Expenses (% of total expenses) of Portugal?
Your response must be concise. 0.98. 